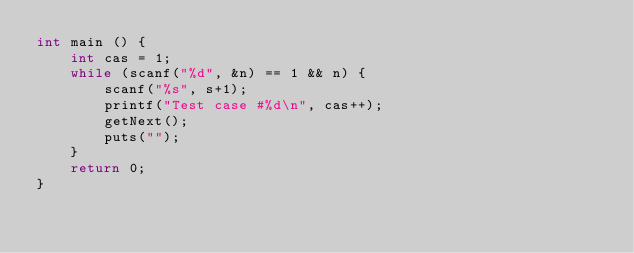Convert code to text. <code><loc_0><loc_0><loc_500><loc_500><_C++_>int main () {
	int cas = 1;
	while (scanf("%d", &n) == 1 && n) {
		scanf("%s", s+1);
		printf("Test case #%d\n", cas++);
		getNext();
		puts("");
	}
	return 0;
}</code> 